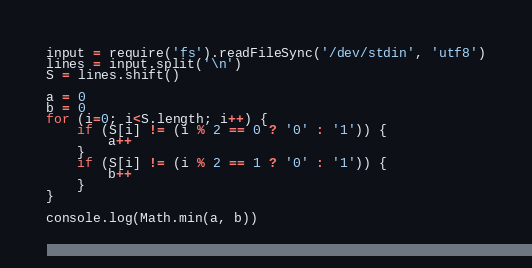Convert code to text. <code><loc_0><loc_0><loc_500><loc_500><_JavaScript_>input = require('fs').readFileSync('/dev/stdin', 'utf8')
lines = input.split('\n')
S = lines.shift()

a = 0
b = 0
for (i=0; i<S.length; i++) {
    if (S[i] != (i % 2 == 0 ? '0' : '1')) {
        a++
    }
    if (S[i] != (i % 2 == 1 ? '0' : '1')) {
        b++
    }
}

console.log(Math.min(a, b))</code> 